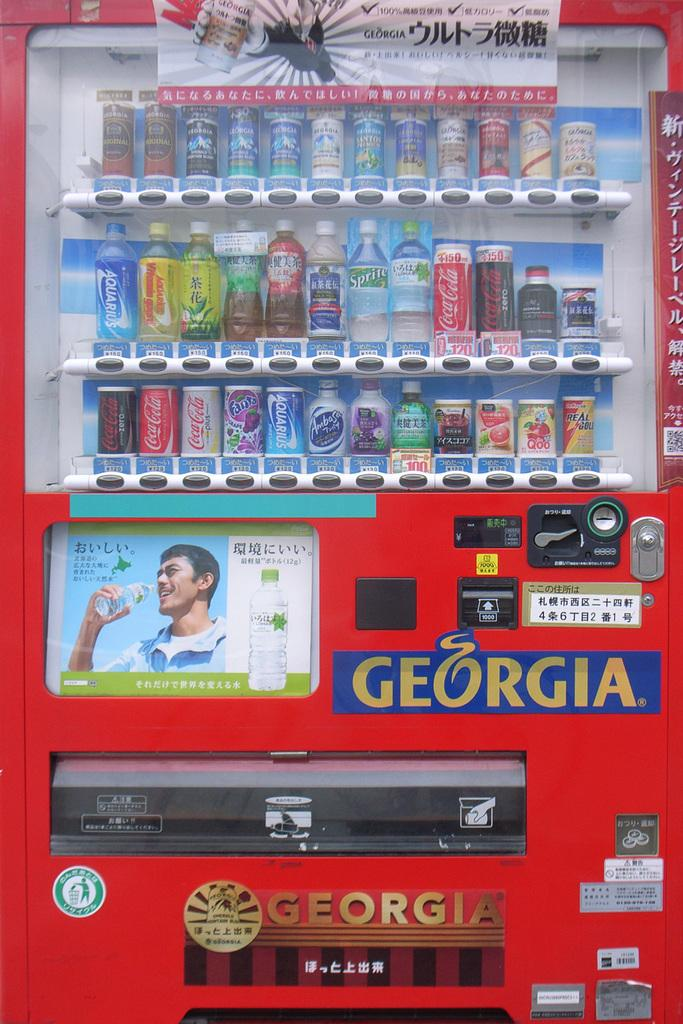What is the main object in the image? There is a vending machine in the image. What types of items are available in the vending machine? The vending machine contains bottles and cans. Are there any additional features on the vending machine? Yes, there are posters attached to the vending machine. What type of insurance is being advertised on the vending machine? There is no insurance being advertised on the vending machine in the image. 